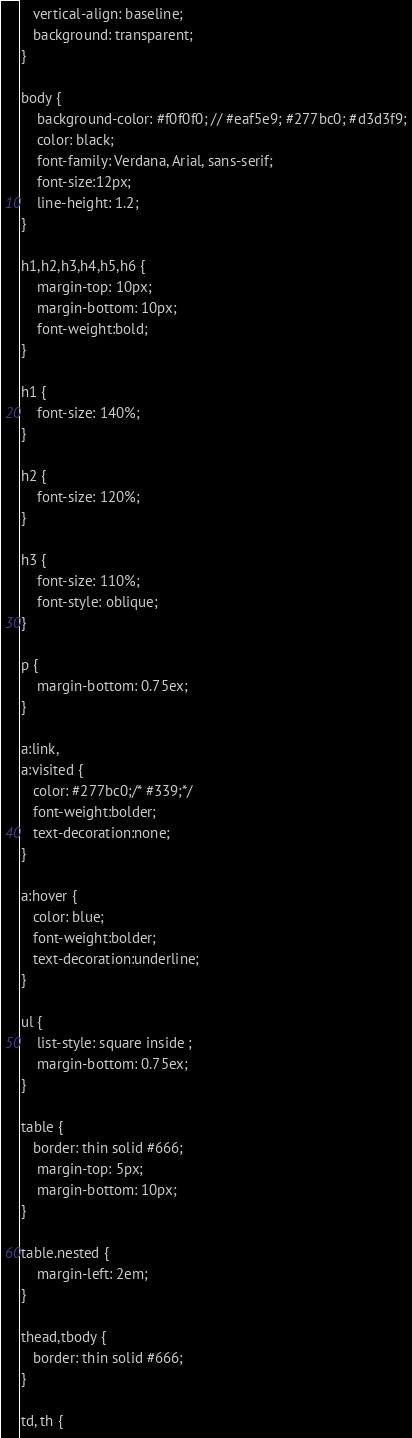Convert code to text. <code><loc_0><loc_0><loc_500><loc_500><_HTML_>   vertical-align: baseline;
   background: transparent;
}

body {
	background-color: #f0f0f0; // #eaf5e9; #277bc0; #d3d3f9;
	color: black;
	font-family: Verdana, Arial, sans-serif; 
	font-size:12px; 
	line-height: 1.2;
}
 
h1,h2,h3,h4,h5,h6 {
	margin-top: 10px;
	margin-bottom: 10px;
	font-weight:bold;
}

h1 {
	font-size: 140%;
}

h2 {
	font-size: 120%;
}

h3 {
	font-size: 110%;
	font-style: oblique;
}

p {
	margin-bottom: 0.75ex;
}

a:link,
a:visited {
   color: #277bc0;/* #339;*/
   font-weight:bolder; 
   text-decoration:none; 
}

a:hover {
   color: blue;
   font-weight:bolder; 
   text-decoration:underline; 
}

ul {
	list-style: square inside ;
	margin-bottom: 0.75ex;
}

table {
   border: thin solid #666;
	margin-top: 5px;
	margin-bottom: 10px;
}

table.nested {
	margin-left: 2em;
}

thead,tbody {
   border: thin solid #666;
}

td, th {</code> 